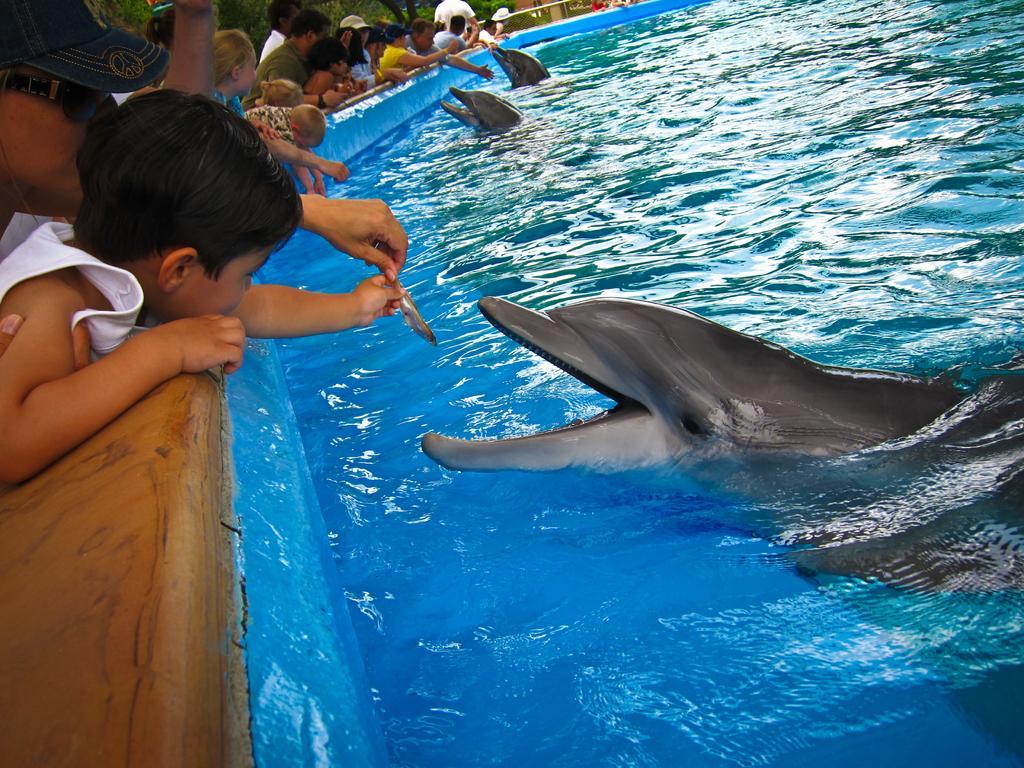In one or two sentences, can you explain what this image depicts? This picture shows people feeding dolphins with small fishes in the water 